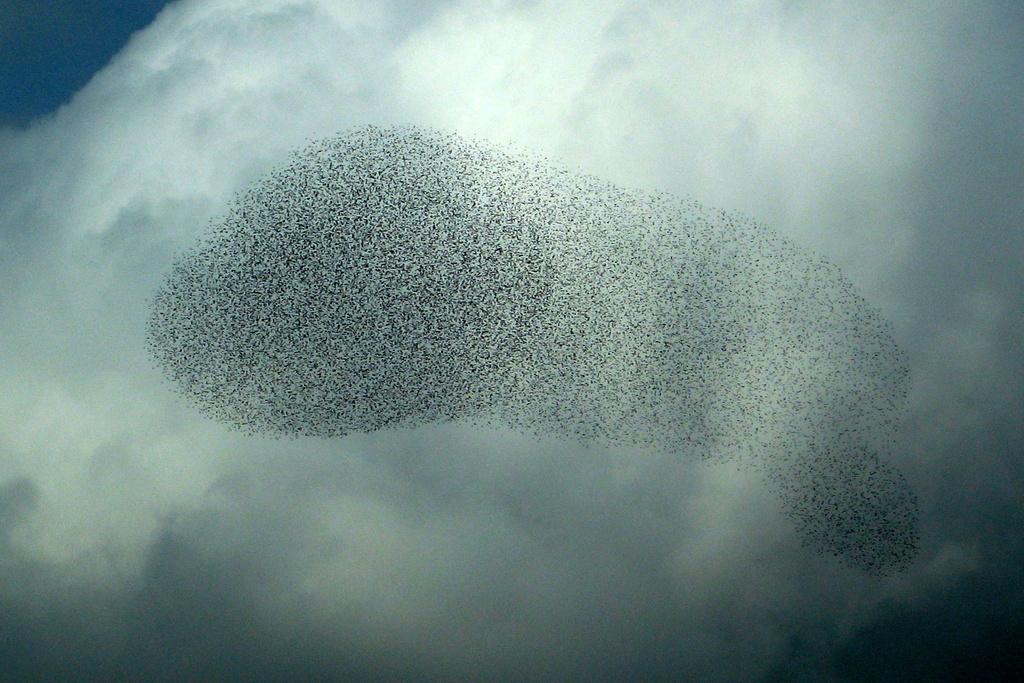Please provide a concise description of this image. In the middle of this image, there are starling murmurations in the air. In the background, there are clouds in the sky. 